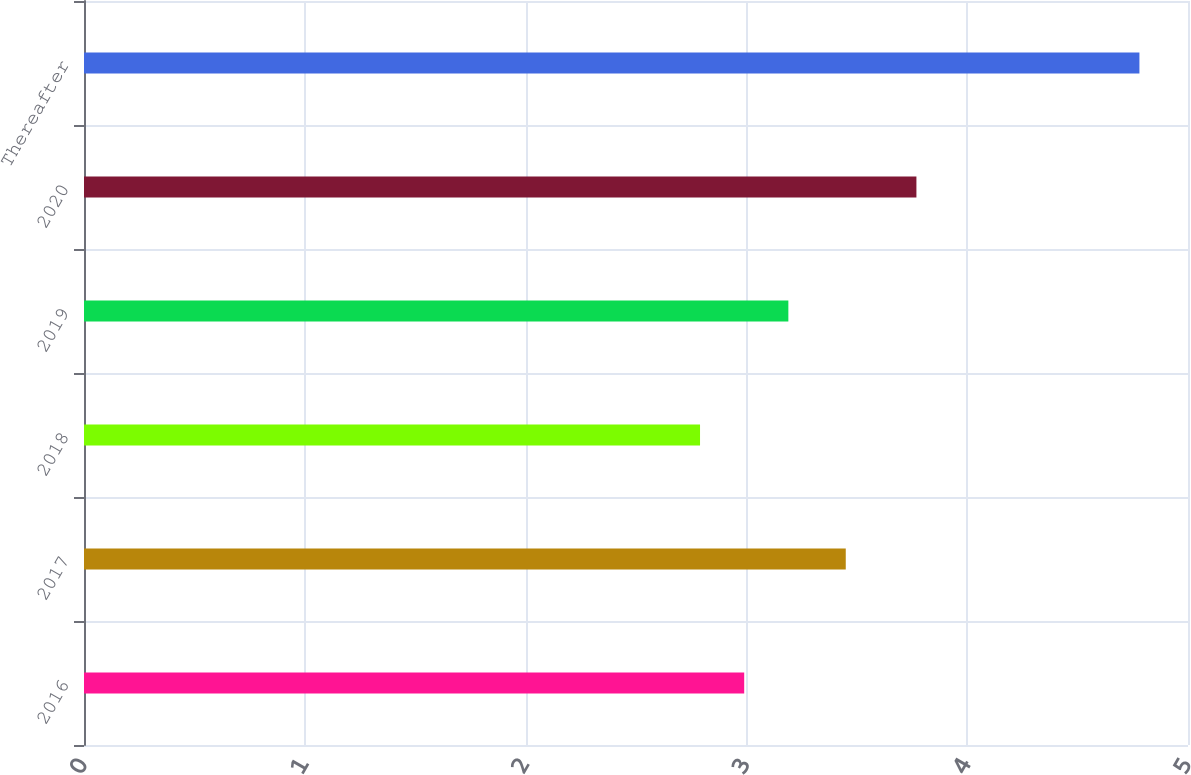Convert chart. <chart><loc_0><loc_0><loc_500><loc_500><bar_chart><fcel>2016<fcel>2017<fcel>2018<fcel>2019<fcel>2020<fcel>Thereafter<nl><fcel>2.99<fcel>3.45<fcel>2.79<fcel>3.19<fcel>3.77<fcel>4.78<nl></chart> 